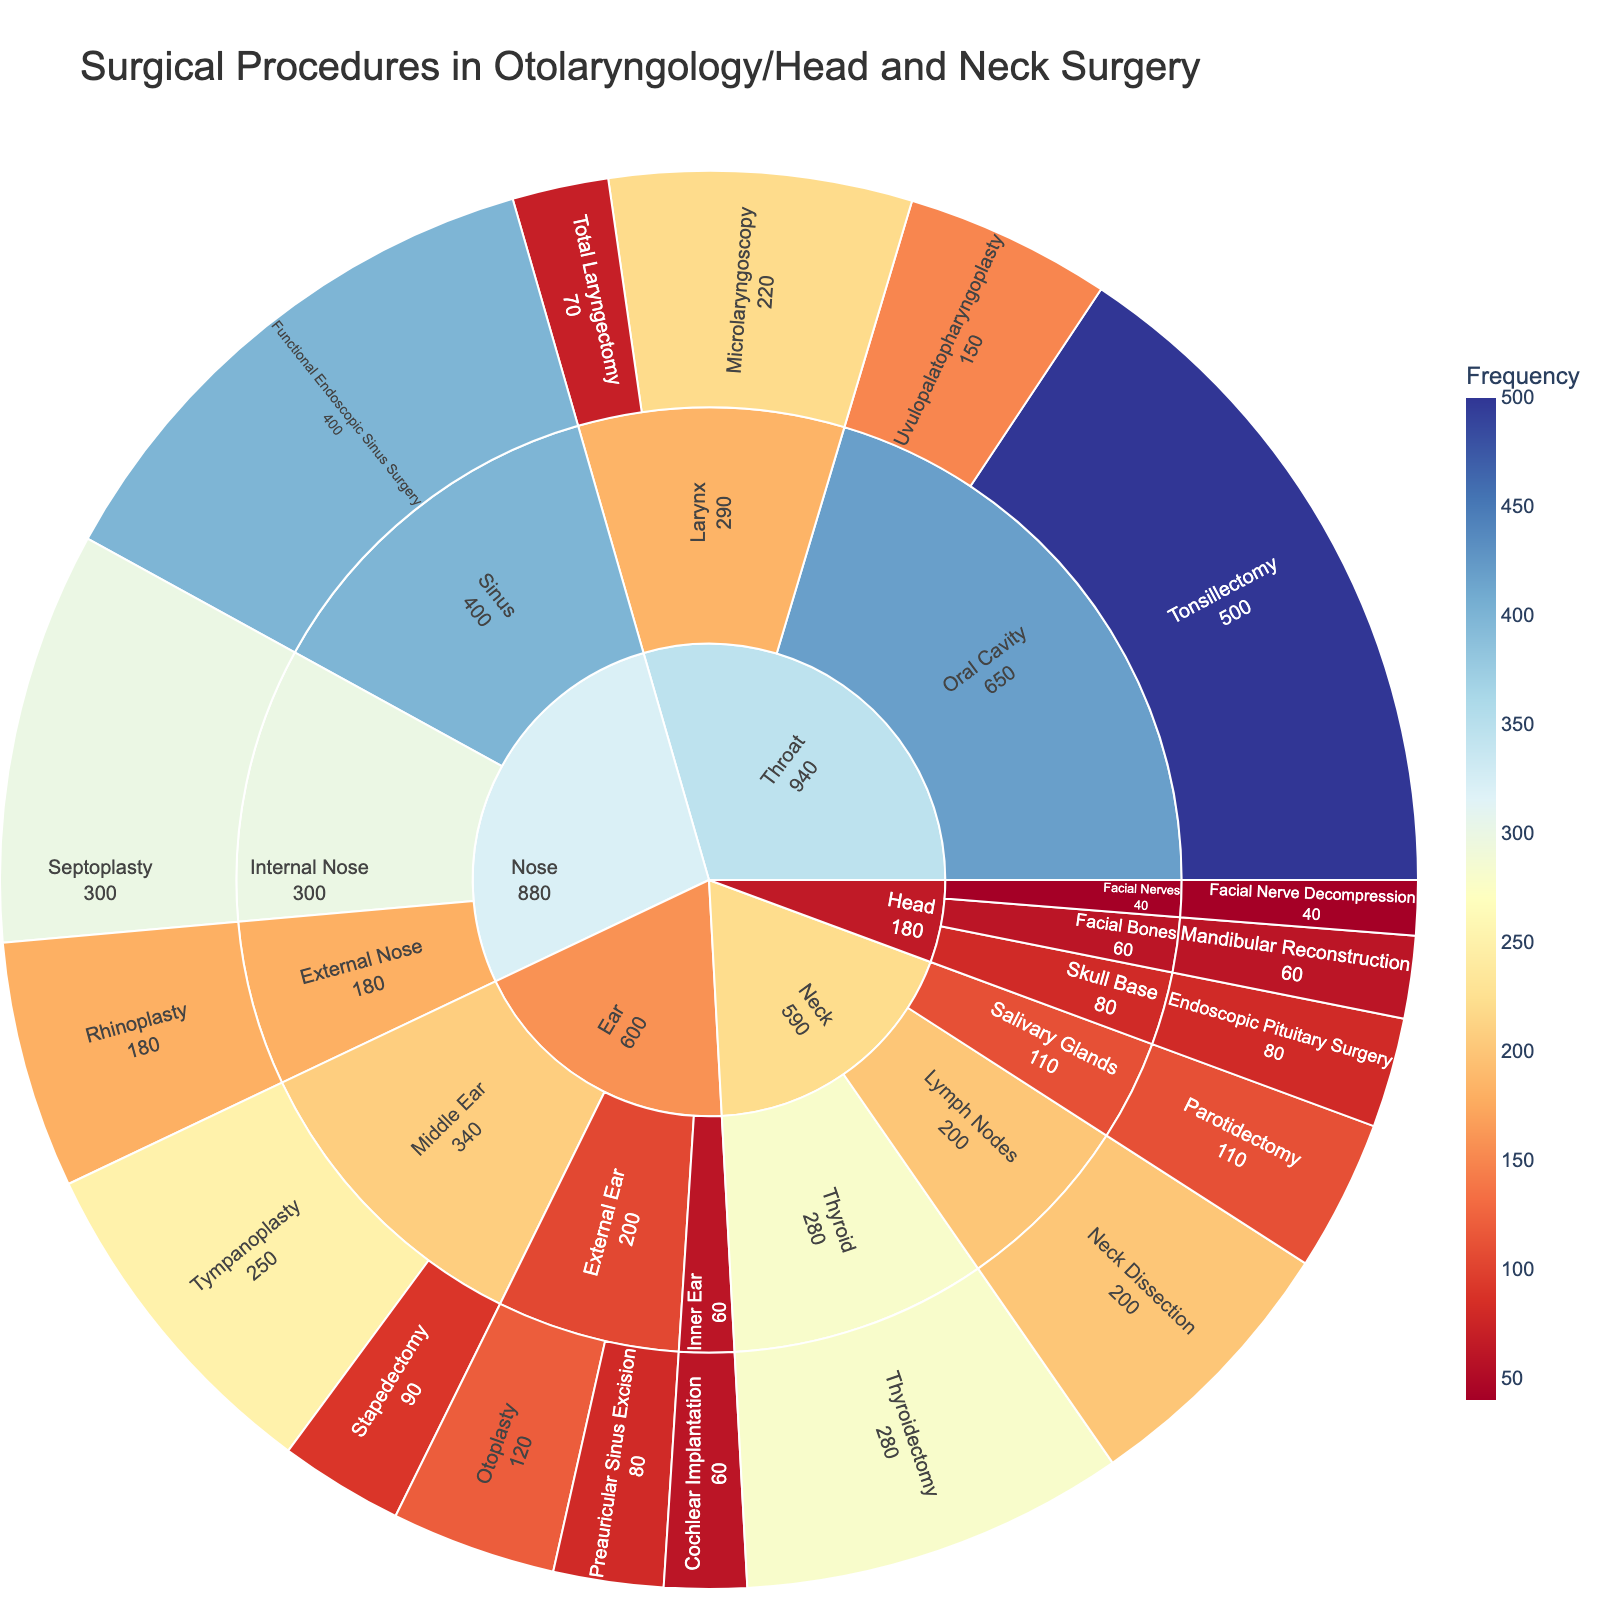What is the title of the figure? The title is located at the top of the figure and is used to indicate the main topic of the visualization.
Answer: Surgical Procedures in Otolaryngology/Head and Neck Surgery Which category has the highest number of surgical procedures? Look at the outermost ring to identify the category with the highest cumulative values. The 'Throat' has the highest frequency with a sum of its subcategories' values.
Answer: Throat How many procedures fall under the 'Nose' category? Sum the frequencies of all procedures that fall under the 'Nose' category: (External Nose: 180, Internal Nose: 300, Sinus: 400). The total is 180 + 300 + 400.
Answer: 880 Which specific procedure has the highest frequency? Look for the procedure with the largest value displayed in its segment. 'Tonsillectomy' in the 'Throat > Oral Cavity' category has the highest value.
Answer: Tonsillectomy What is the frequency difference between 'Thyroidectomy' and 'Rhinoplasty'? Subtract the frequency of 'Rhinoplasty' from 'Thyroidectomy': 280 (Thyroidectomy) - 180 (Rhinoplasty).
Answer: 100 Between 'Tympanoplasty' and 'Septoplasty', which procedure is performed more frequently? Compare the frequencies of both procedures. 'Septoplasty' has a higher frequency (300) compared to 'Tympanoplasty' (250).
Answer: Septoplasty Which procedure under the 'Ear' category has the lowest frequency? Check the values for all procedures under 'Ear' and find the smallest one. 'Cochlear Implantation' in 'Inner Ear' has the lowest frequency.
Answer: Cochlear Implantation Name two subcategories under the 'Throat' category. Navgivate to the 'Throat' section and identify the subcategories under it. There are 'Oral Cavity' and 'Larynx'.
Answer: Oral Cavity, Larynx How many procedures are there in the 'Head' category? Count all the procedures under the 'Head' category in the figure. Specifically, there are three subcategories with one procedure each.
Answer: 3 Is 'Total Laryngectomy' more frequent than 'Stapedectomy'? Compare the frequency values of both procedures. 'Microlaryngoscopy' (70) has a lower frequency than 'Stapedectomy' (90).
Answer: No 